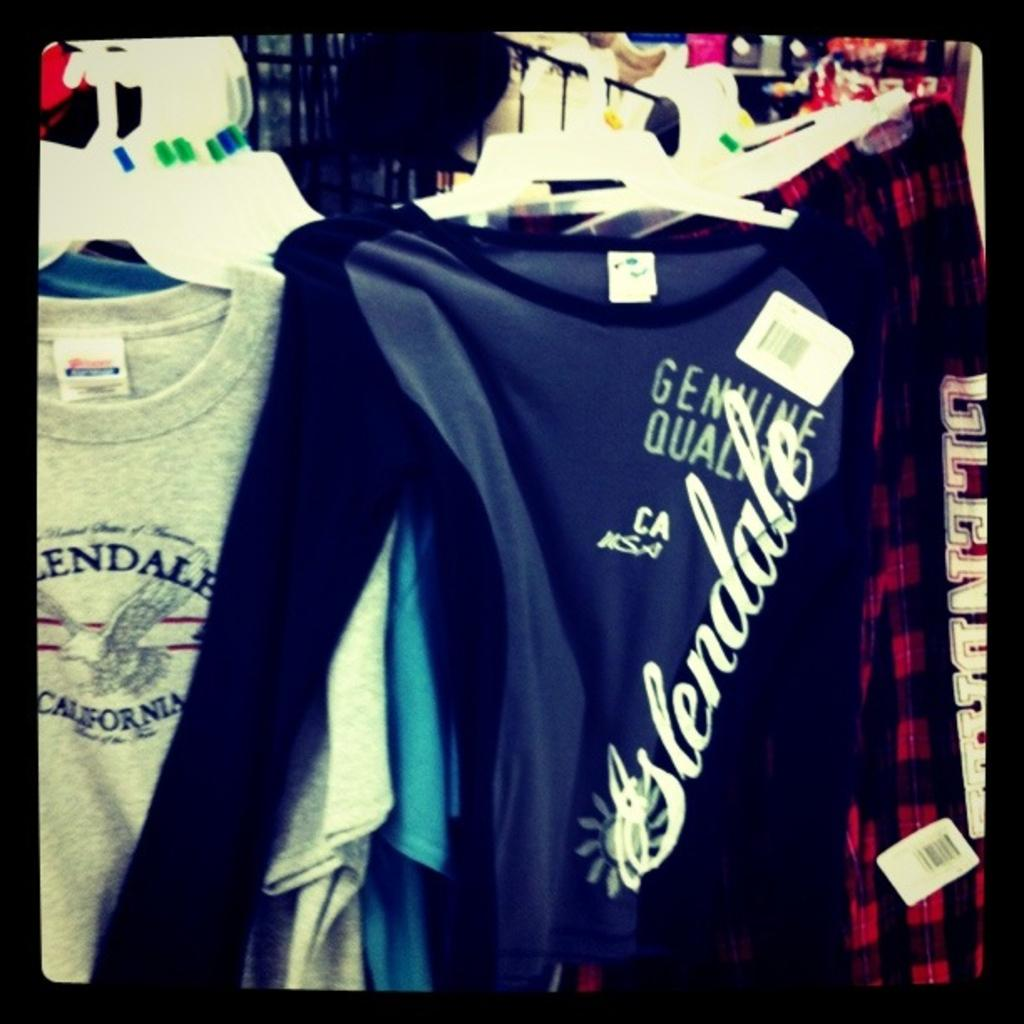<image>
Present a compact description of the photo's key features. A collection of shirt with the front one reading Glendale. 